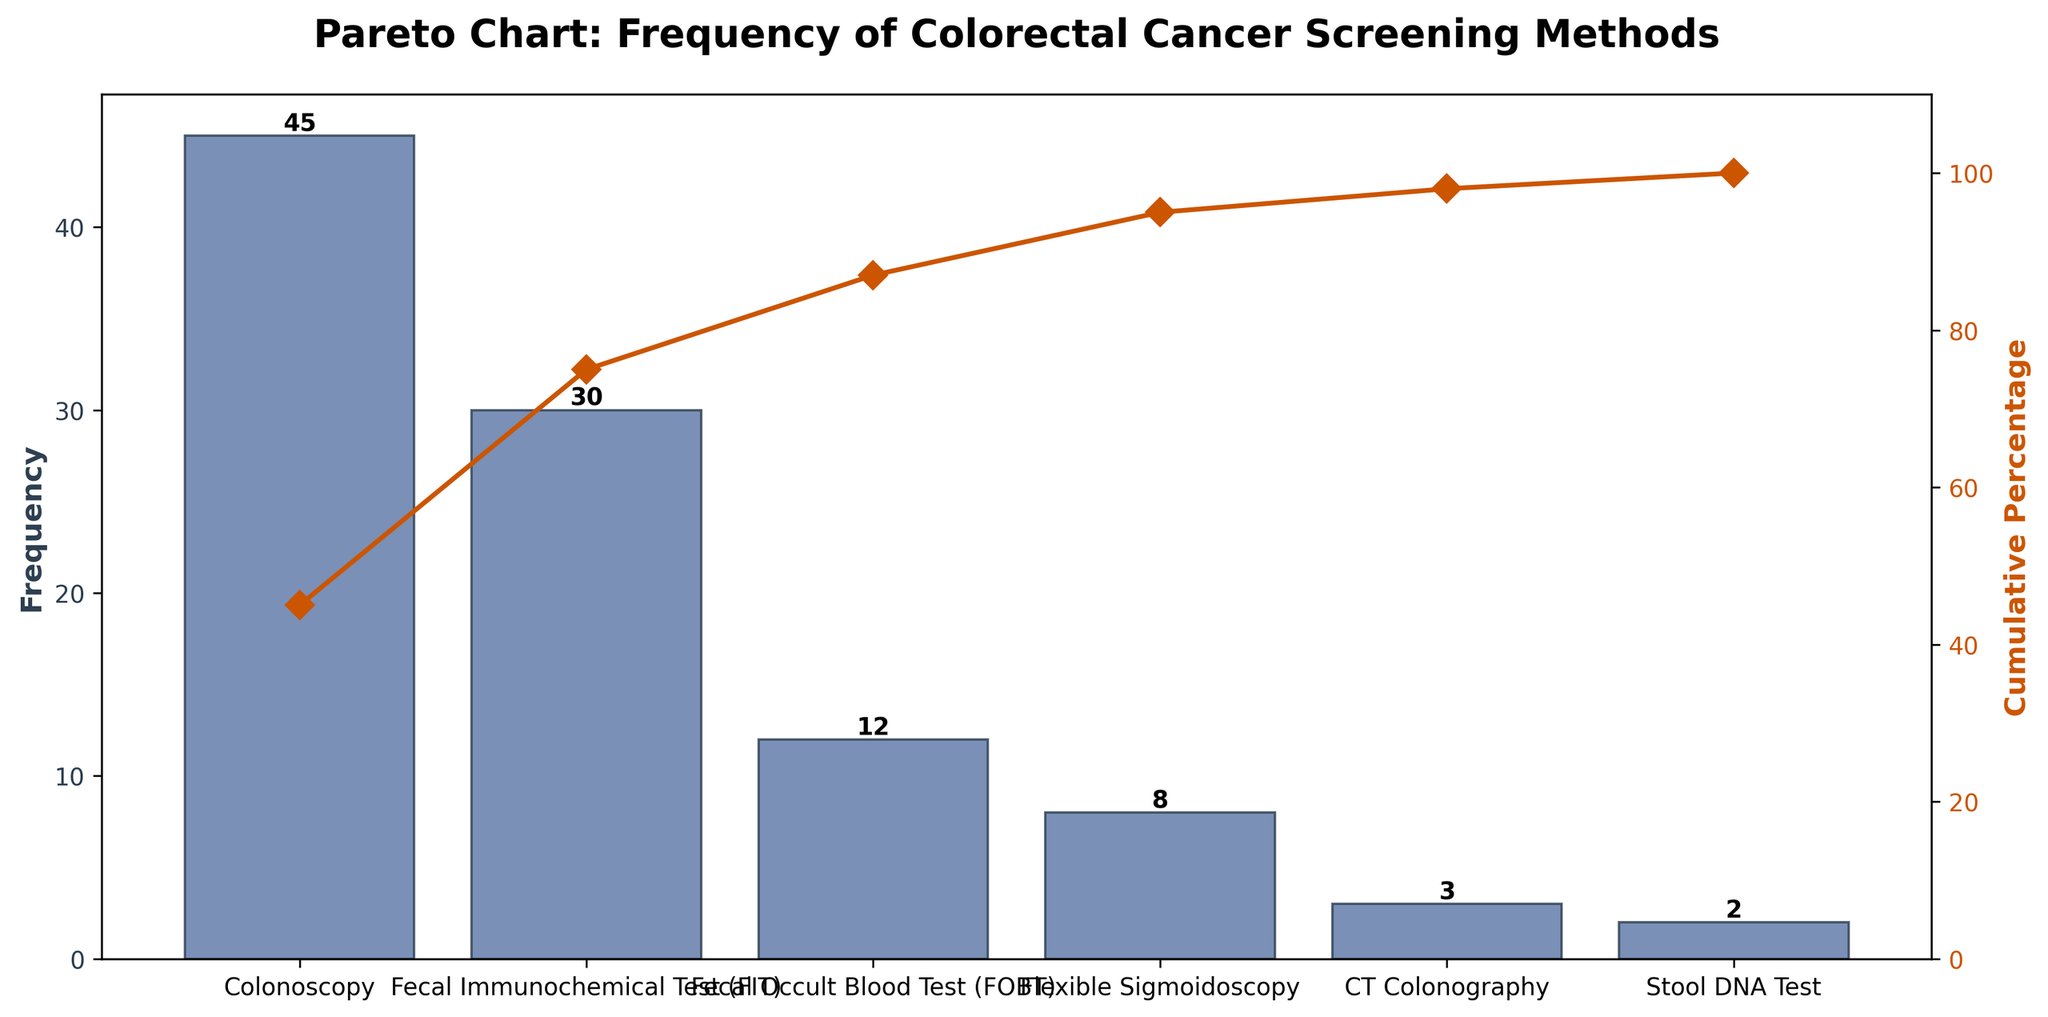What is the title of the figure? The title of the figure is displayed at the top and reads "Pareto Chart: Frequency of Colorectal Cancer Screening Methods".
Answer: Pareto Chart: Frequency of Colorectal Cancer Screening Methods How many screening methods are displayed in the chart? The x-axis lists the different screening methods, and there are six bars corresponding to each screening method.
Answer: Six Which screening method is the most frequently used? The tallest bar corresponds to "Colonoscopy", indicating it is the most frequently used screening method.
Answer: Colonoscopy What is the cumulative percentage when considering the top two screening methods? The cumulative percentages are displayed on the secondary y-axis, the cumulative percentage for "Colonoscopy" and "Fecal Immunochemical Test (FIT)" combined is 45/100*100 + 30/100*100 = 75%.
Answer: 75% What is the cumulative percentage after including the top three screening methods? Adding the frequencies of the top three screening methods: Colonoscopy (45), FIT (30), and FOBT (12), and then computing the percentage: (45 + 30 + 12) / 100 * 100 = 87%.
Answer: 87% By how much does the frequency of Colonoscopy exceed the frequency of Flexible Sigmoidoscopy? The frequency of Colonoscopy is 45 and that of Flexible Sigmoidoscopy is 8, so the difference is 45 - 8.
Answer: 37 What is the least frequently used screening method? The shortest bar represents the "Stool DNA Test", indicating it is the least frequently used screening method.
Answer: Stool DNA Test How does the frequency of the Fecal Occult Blood Test (FOBT) compare to that of the Stool DNA Test? FOBT has a frequency of 12, whereas the Stool DNA Test has a frequency of 2. Thus, FOBT is used 6 times more frequently than the Stool DNA Test.
Answer: 6 times more frequent What percentage of the total frequency is accounted for by the least frequently used method? The total frequency is 100, and the least frequently used method (Stool DNA Test) has a frequency of 2, so the percentage is 2/100*100.
Answer: 2% What is the cumulative percentage for the top four screening methods? Summing the frequencies of the top four screening methods: Colonoscopy (45), FIT (30), FOBT (12), and Flexible Sigmoidoscopy (8) gives 45 + 30 + 12 + 8 = 95. The cumulative percentage is (95/100) * 100 = 95%.
Answer: 95% 